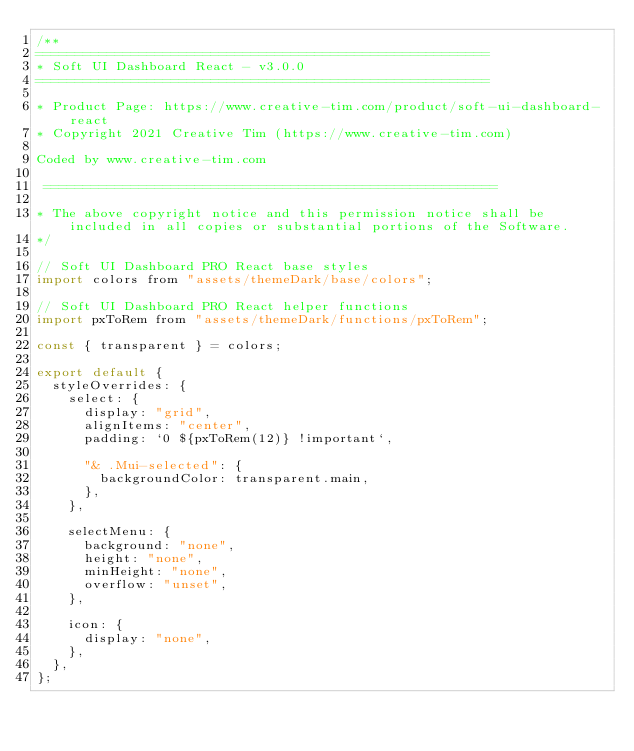Convert code to text. <code><loc_0><loc_0><loc_500><loc_500><_JavaScript_>/**
=========================================================
* Soft UI Dashboard React - v3.0.0
=========================================================

* Product Page: https://www.creative-tim.com/product/soft-ui-dashboard-react
* Copyright 2021 Creative Tim (https://www.creative-tim.com)

Coded by www.creative-tim.com

 =========================================================

* The above copyright notice and this permission notice shall be included in all copies or substantial portions of the Software.
*/

// Soft UI Dashboard PRO React base styles
import colors from "assets/themeDark/base/colors";

// Soft UI Dashboard PRO React helper functions
import pxToRem from "assets/themeDark/functions/pxToRem";

const { transparent } = colors;

export default {
  styleOverrides: {
    select: {
      display: "grid",
      alignItems: "center",
      padding: `0 ${pxToRem(12)} !important`,

      "& .Mui-selected": {
        backgroundColor: transparent.main,
      },
    },

    selectMenu: {
      background: "none",
      height: "none",
      minHeight: "none",
      overflow: "unset",
    },

    icon: {
      display: "none",
    },
  },
};
</code> 